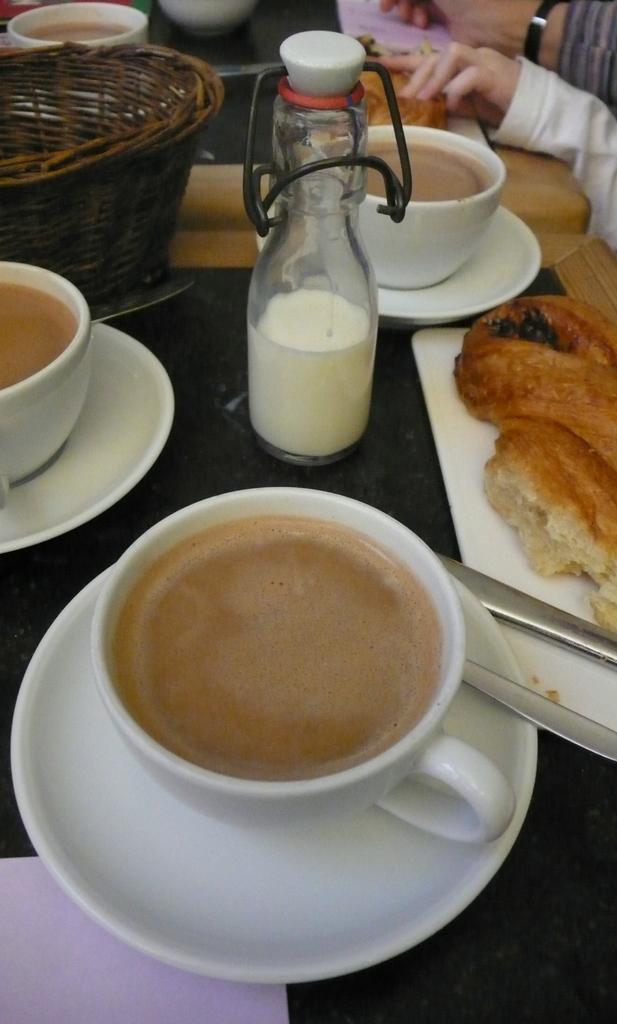Could you give a brief overview of what you see in this image? In this picture we can see cups with drinks in it, saucers, basket, bottle, food items, knife, paper and these all are placed on tables and beside these tables we can see some persons hands. 